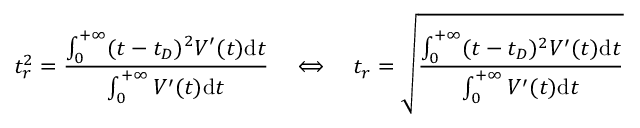Convert formula to latex. <formula><loc_0><loc_0><loc_500><loc_500>t _ { r } ^ { 2 } = { \frac { \int _ { 0 } ^ { + \infty } ( t - t _ { D } ) ^ { 2 } V ^ { \prime } ( t ) d t } { \int _ { 0 } ^ { + \infty } V ^ { \prime } ( t ) d t } } \quad \Longleftrightarrow \quad t _ { r } = { \sqrt { \frac { \int _ { 0 } ^ { + \infty } ( t - t _ { D } ) ^ { 2 } V ^ { \prime } ( t ) d t } { \int _ { 0 } ^ { + \infty } V ^ { \prime } ( t ) d t } } }</formula> 